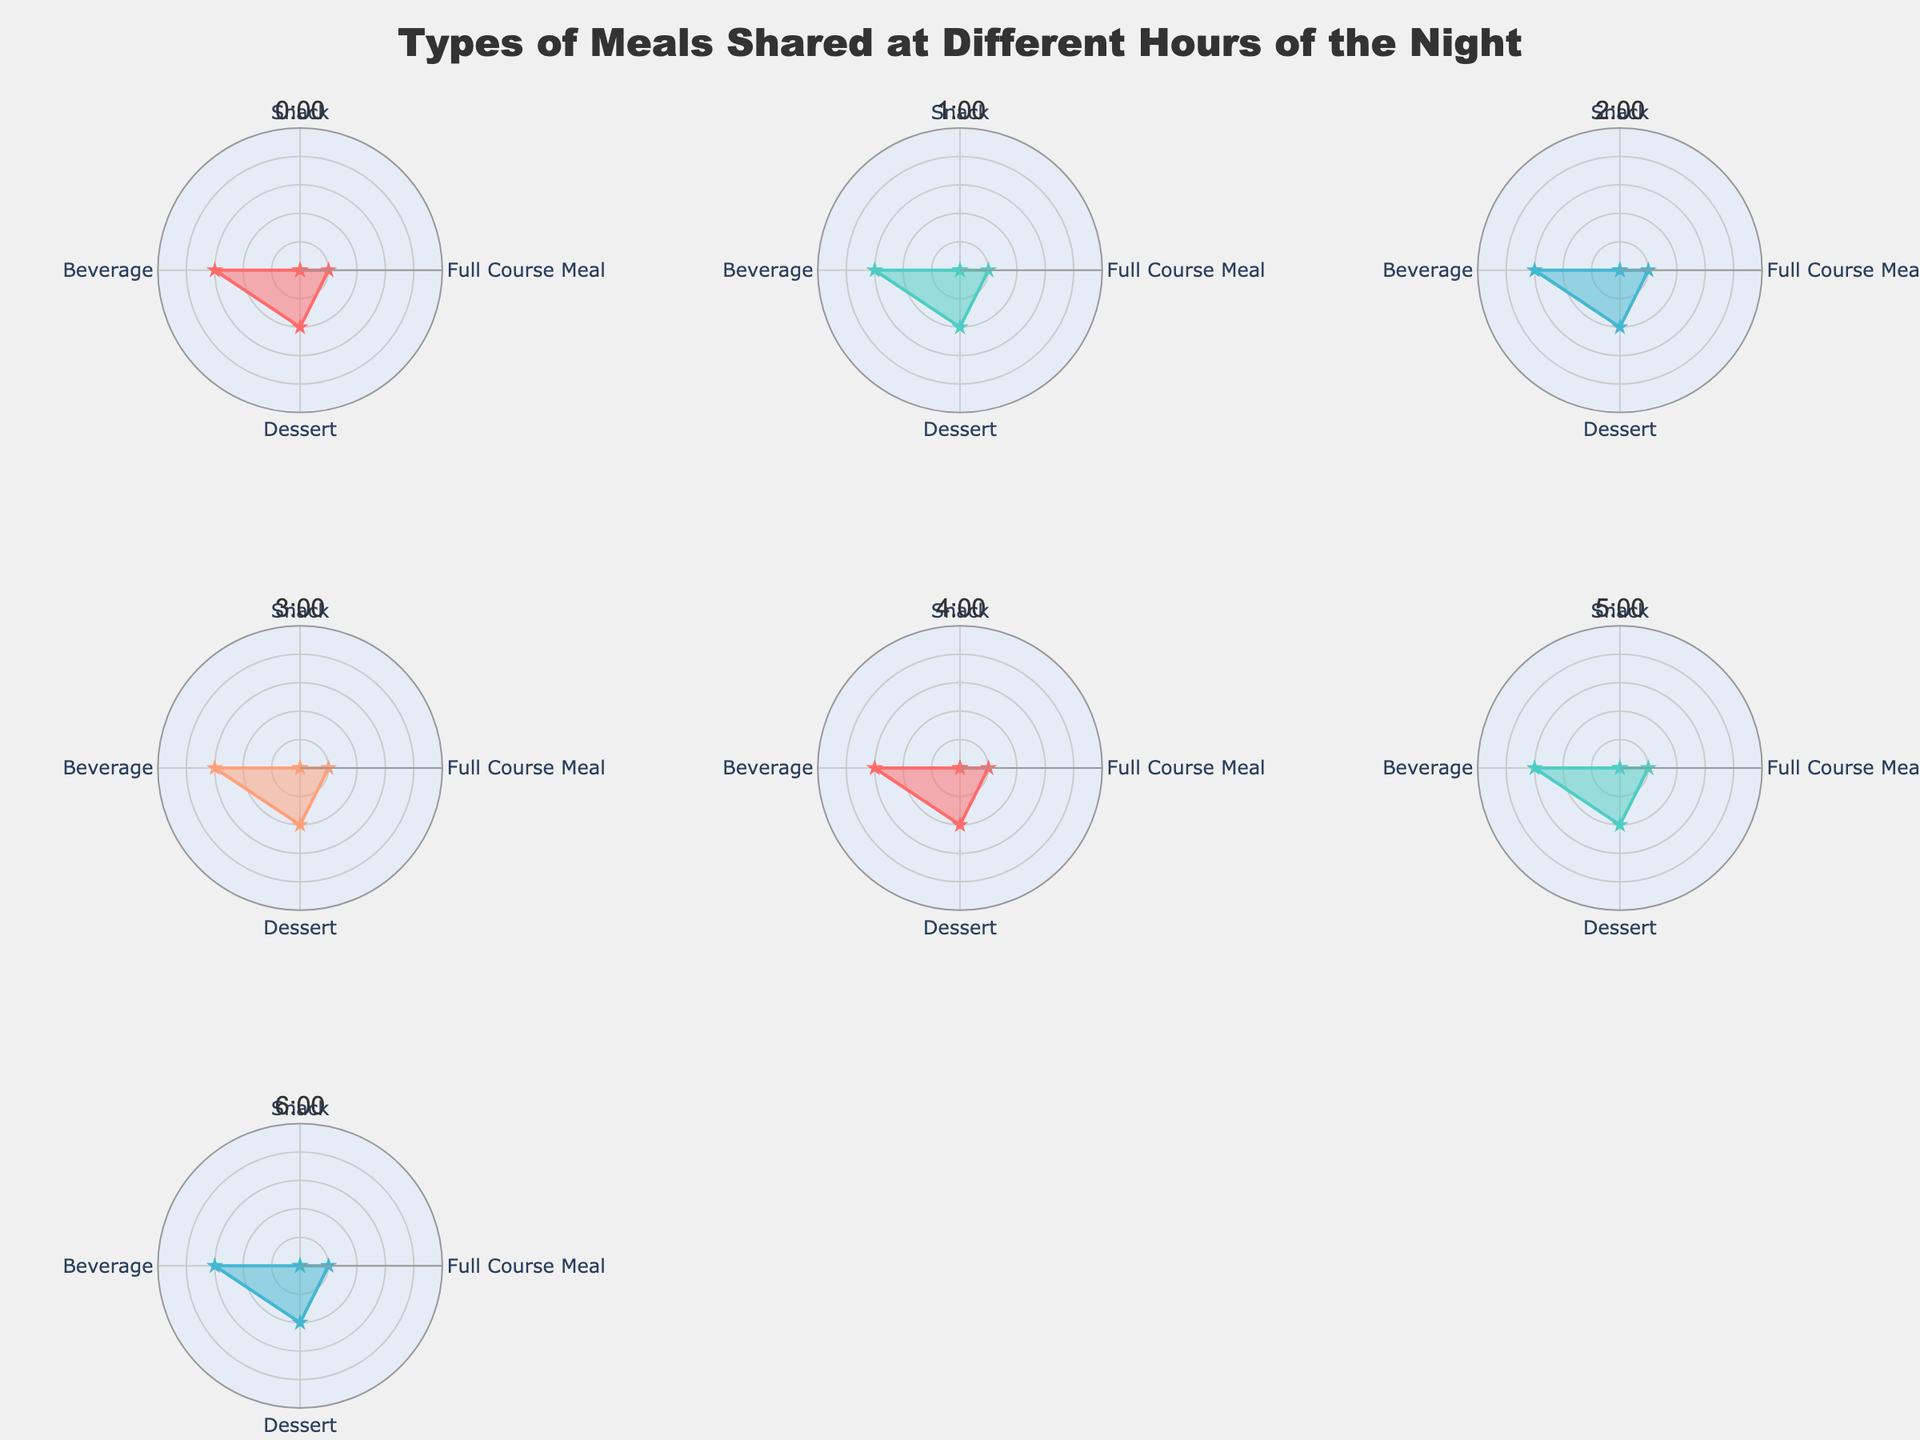What is the title of the chart? The title is prominently displayed and should be one of the first elements that catch the eye. It gives an overview of what the chart represents.
Answer: Types of Meals Shared at Different Hours of the Night How many subplots are there in the figure? Each hour of the night has a separate subplot, and they are arranged in a grid format. Count the number of subplots to get the answer.
Answer: 7 At which hour is Popcorn recorded as a snack? Identify the subplot for each hour and look specifically at the snack category within each radar chart.
Answer: 4:00 Which hour features both Tiramisu and Green Tea? Locate the hours where each type of meal and beverage is represented by checking the labels within each radar chart. Find the common hour between Tiramisu and Green Tea.
Answer: 3:00 Compare the snack shared at 2:00 and the snack shared at 5:00. Which one is healthier? Look at the labels for snacks in the subplots for 2:00 and 5:00. Assess healthiness based on common nutritional knowledge (Pretzels vs. Crackers).
Answer: Crackers are generally considered healthier than Pretzels Which hour has the most varied types of meals from different categories (Snacks, Full Course Meals, Desserts, Beverages)? To answer this, evaluate each radar chart's variety by noting how diverse the names in the categories are and decide which hour has the most distinctive entries across all categories.
Answer: 1:00 (Granola Bar, Steak and Eggs, Chocolate Cake, Herbal Tea) What's the predominate dessert consumed after midnight? Examine the dessert category across each hour's radar chart to see which dessert appears most frequently after midnight (0:00 onward).
Answer: Chocolate Cake and Cheesecake both appear once, no single predominant dessert For which hours are the radar chart lines colored with the same color? Color code repetition can easily be seen by comparing the line colors of radar charts. Identify hours that share colors.
Answer: 0:00 and 4:00 (color consistency example, needs visual confirmation for exact detail) What’s the line color for the 3:00 radar chart? Look at the colored line representing the 3:00 hour's radar chart to identify its color visually from the custom color palette used.
Answer: Blue What’s the smallest individual meal item shared across all hours? Review each radar chart to find the meal item that stands out as potentially being the smallest in portion size (e.g., Trail Mix, Granola Bar).
Answer: Nuts 